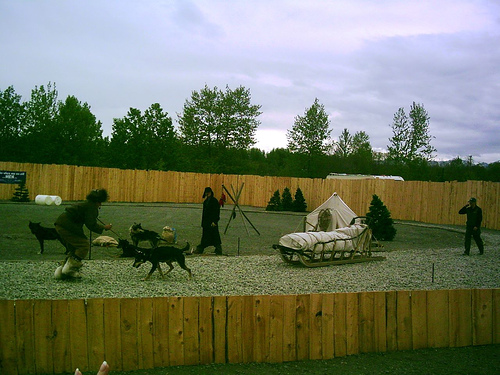Can you describe the activity taking place and the kind of environment it's in? Certainly. The image shows dogs engaged in a sled activity, reflecting a simulation or practice of sled pulling which is often associated with colder regions. However, the absence of snow and the presence of green foliage in the background suggest that this exercise might be taking place in a warmer climate or during off-season training. The environment looks like a dedicated training ground, surrounded by a wooden fence, and made to emulate sled pulling conditions. 